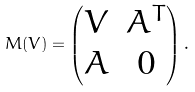Convert formula to latex. <formula><loc_0><loc_0><loc_500><loc_500>M ( V ) = \begin{pmatrix} V & A ^ { T } \\ A & 0 \end{pmatrix} .</formula> 